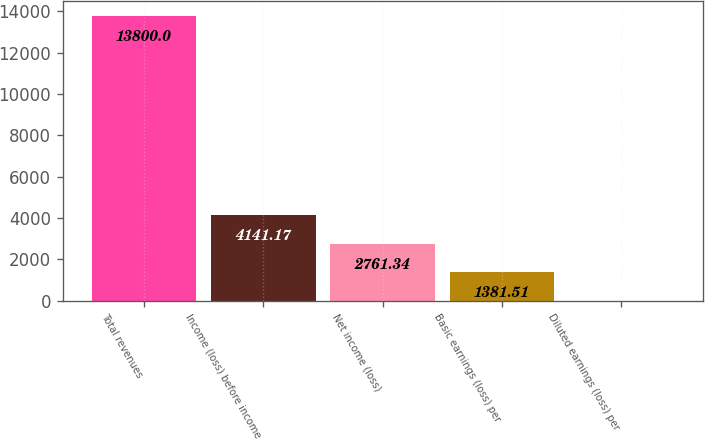<chart> <loc_0><loc_0><loc_500><loc_500><bar_chart><fcel>Total revenues<fcel>Income (loss) before income<fcel>Net income (loss)<fcel>Basic earnings (loss) per<fcel>Diluted earnings (loss) per<nl><fcel>13800<fcel>4141.17<fcel>2761.34<fcel>1381.51<fcel>1.68<nl></chart> 